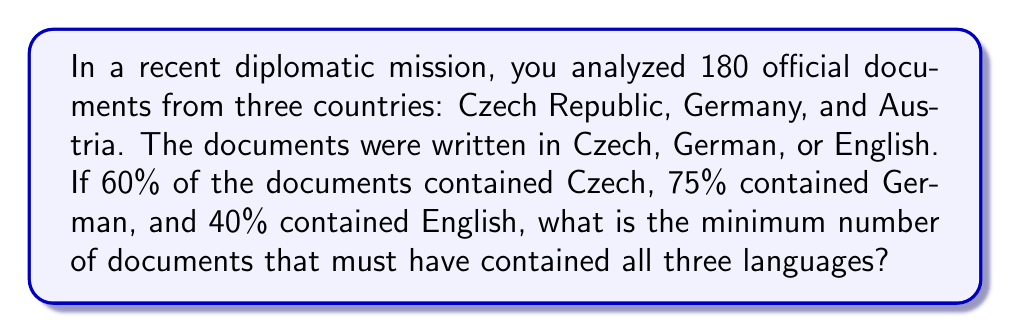Solve this math problem. Let's approach this step-by-step using the principle of inclusion-exclusion:

1) Let's define our sets:
   C: documents containing Czech
   G: documents containing German
   E: documents containing English

2) We know:
   $|C| = 0.60 \times 180 = 108$
   $|G| = 0.75 \times 180 = 135$
   $|E| = 0.40 \times 180 = 72$

3) The principle of inclusion-exclusion states:
   $$|C \cup G \cup E| = |C| + |G| + |E| - |C \cap G| - |C \cap E| - |G \cap E| + |C \cap G \cap E|$$

4) We know that $|C \cup G \cup E| \leq 180$ (total number of documents)

5) Substituting the known values:
   $$180 \geq 108 + 135 + 72 - |C \cap G| - |C \cap E| - |G \cap E| + |C \cap G \cap E|$$

6) Simplifying:
   $$180 \geq 315 - |C \cap G| - |C \cap E| - |G \cap E| + |C \cap G \cap E|$$

7) Rearranging:
   $$|C \cap G| + |C \cap E| + |G \cap E| - |C \cap G \cap E| \geq 135$$

8) To minimize $|C \cap G \cap E|$, we need to maximize $|C \cap G| + |C \cap E| + |G \cap E|$

9) The maximum possible values for these intersections are:
   $|C \cap G| \leq 108$, $|C \cap E| \leq 72$, $|G \cap E| \leq 72$

10) Substituting these maximum values:
    $$108 + 72 + 72 - |C \cap G \cap E| \geq 135$$

11) Solving for $|C \cap G \cap E|$:
    $$|C \cap G \cap E| \geq 108 + 72 + 72 - 135 = 117$$

Therefore, the minimum number of documents that must have contained all three languages is 117.
Answer: 117 